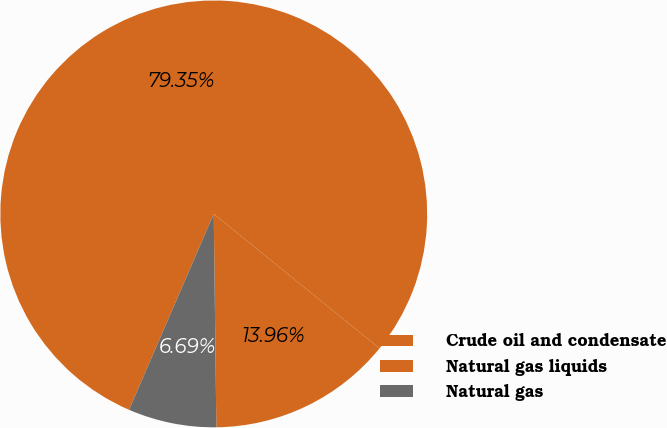<chart> <loc_0><loc_0><loc_500><loc_500><pie_chart><fcel>Crude oil and condensate<fcel>Natural gas liquids<fcel>Natural gas<nl><fcel>79.35%<fcel>13.96%<fcel>6.69%<nl></chart> 